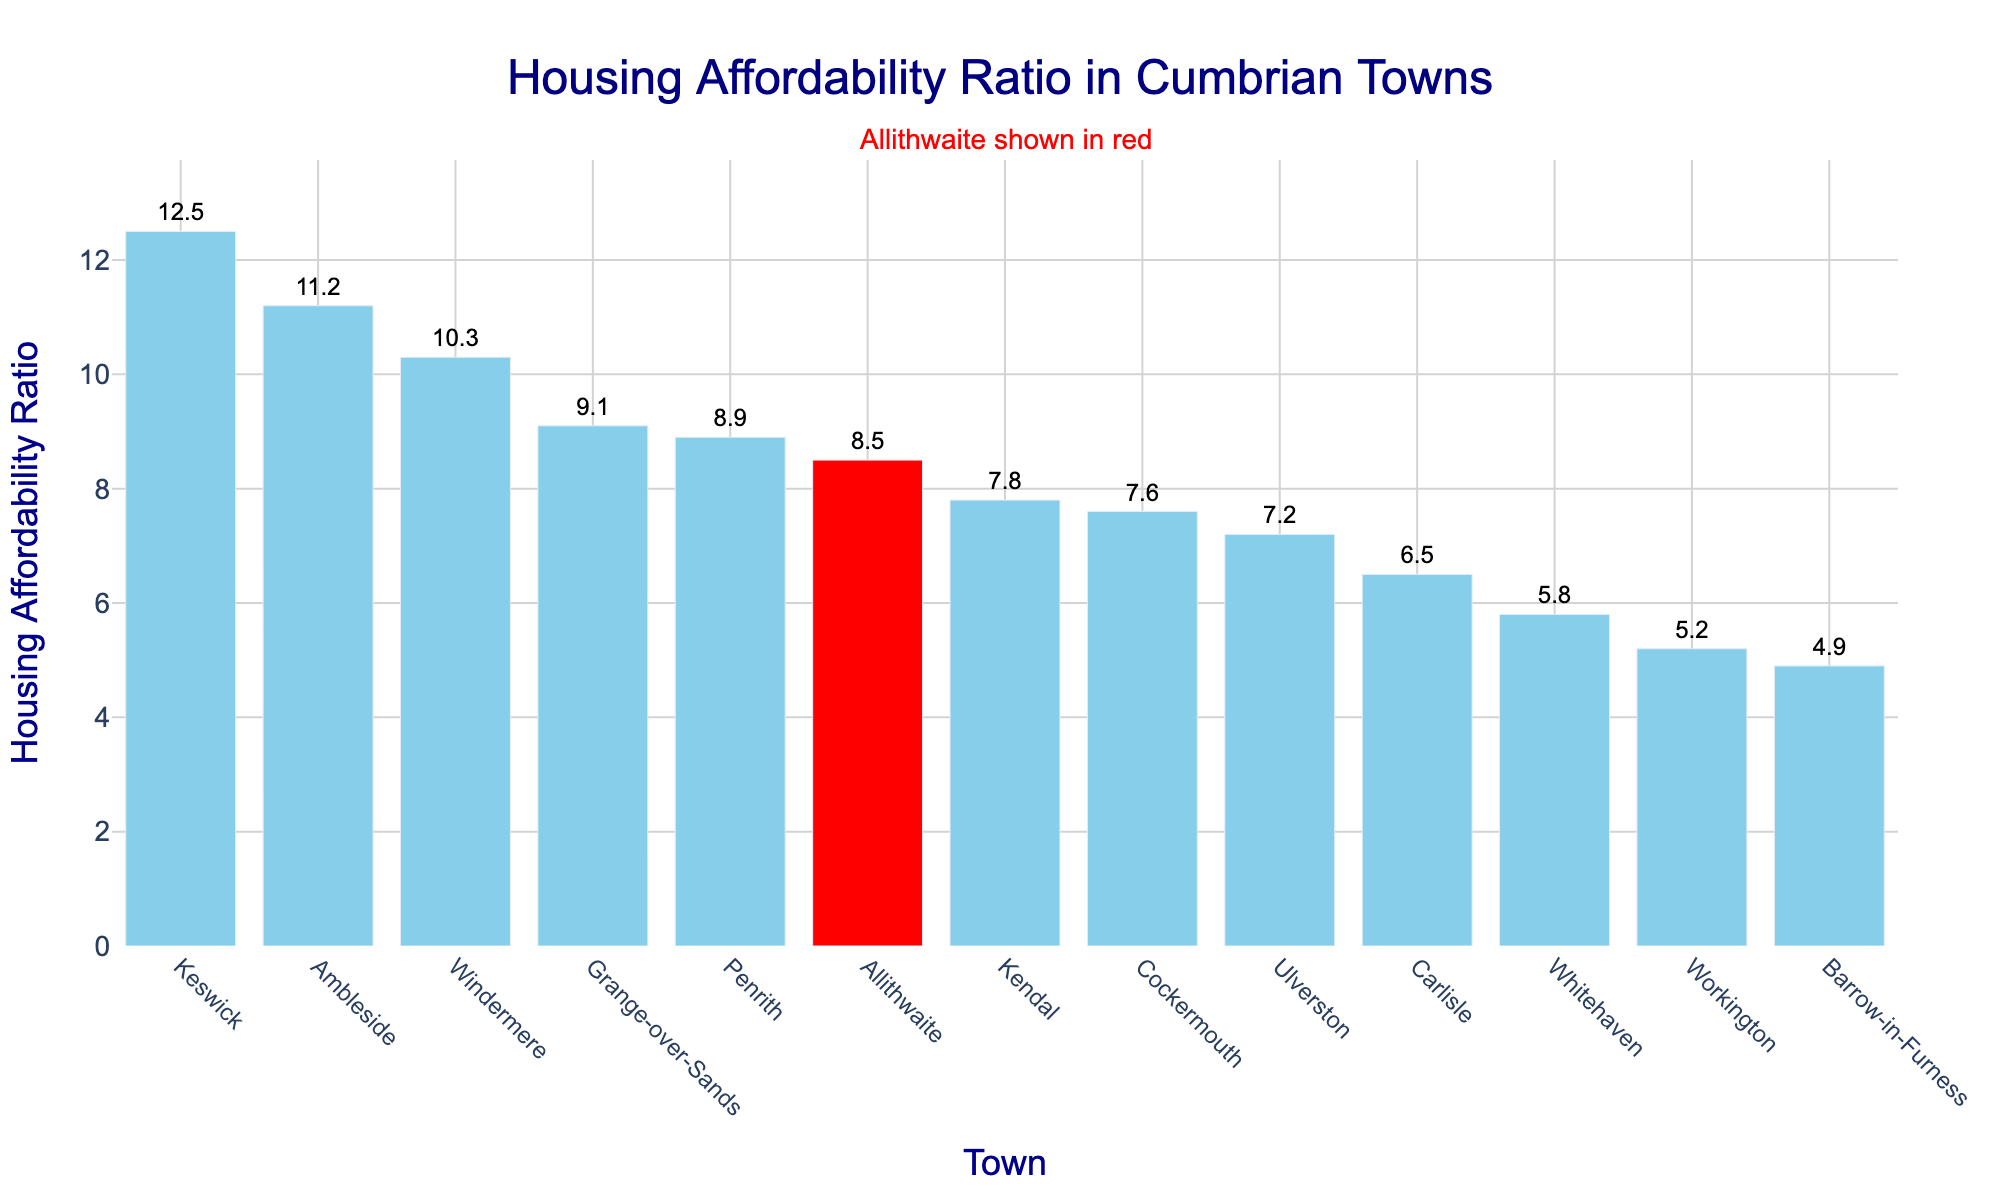How does Allithwaite's housing affordability ratio compare to the average ratio of all the towns? To find the average housing affordability ratio, sum up the ratios of all towns and divide by the number of towns. The sum is (8.5 + 7.8 + 7.2 + 9.1 + 10.3 + 11.2 + 12.5 + 8.9 + 6.5 + 5.8 + 5.2 + 7.6 + 4.9) = 105.5. The number of towns is 13. The average ratio is 105.5/13 ≈ 8.12. Allithwaite's ratio of 8.5 is higher than the average.
Answer: Allithwaite's ratio is higher What is the difference in housing affordability ratio between Allithwaite and Workington? Allithwaite's ratio is 8.5 and Workington's ratio is 5.2. Subtract Workington's ratio from Allithwaite's ratio: 8.5 - 5.2 = 3.3.
Answer: 3.3 Which town has the highest housing affordability ratio, and how much higher is it than Allithwaite's ratio? The highest ratio is found in Keswick with a ratio of 12.5. The difference between Keswick's ratio and Allithwaite's ratio is 12.5 - 8.5 = 4.
Answer: Keswick, 4 How many towns have a housing affordability ratio higher than Allithwaite? Allithwaite's ratio is 8.5. The towns with higher ratios are Grange-over-Sands (9.1), Windermere (10.3), Ambleside (11.2), and Keswick (12.5). There are 4 such towns.
Answer: 4 Is there a town with the same housing affordability ratio as Allithwaite? Looking at the ratios, no town has the same ratio of 8.5 as Allithwaite.
Answer: No Which towns have a lower housing affordability ratio than Allithwaite, and what is their average ratio? The towns with lower ratios are Kendal (7.8), Ulverston (7.2), Carlisle (6.5), Whitehaven (5.8), Workington (5.2), Cockermouth (7.6), and Barrow-in-Furness (4.9). Summing their ratios: 7.8 + 7.2 + 6.5 + 5.8 + 5.2 + 7.6 + 4.9 = 45. Summing and dividing by the number of towns: 45 / 7 ≈ 6.43.
Answer: 7 towns, average ratio 6.43 What is the visual characteristic that highlights Allithwaite in the bar chart? Allithwaite is highlighted in red, while other towns are displayed in sky blue.
Answer: Red color Which town is just above and just below Allithwaite in terms of housing affordability ratio? Sorting the list, Grange-over-Sands with a ratio of 9.1 is just above Allithwaite, and Kendal with 7.8 is just below Allithwaite.
Answer: Grange-over-Sands above, Kendal below What is the range of housing affordability ratios among the Cumbrian towns shown? The highest ratio is in Keswick (12.5) and the lowest is in Barrow-in-Furness (4.9). The range is 12.5 - 4.9 = 7.6.
Answer: 7.6 Which town has the closest housing affordability ratio to the median of all the towns? First, find the median ratio. Sorting the ratios: 4.9, 5.2, 5.8, 6.5, 7.2, 7.6, 7.8, 8.5 (Allithwaite), 8.9, 9.1, 10.3, 11.2, 12.5, the median is the 7th and 8th values averaged: (7.8 + 8.5) / 2 = 8.15. Town closest to 8.15 is Allithwaite (8.5).
Answer: Allithwaite 